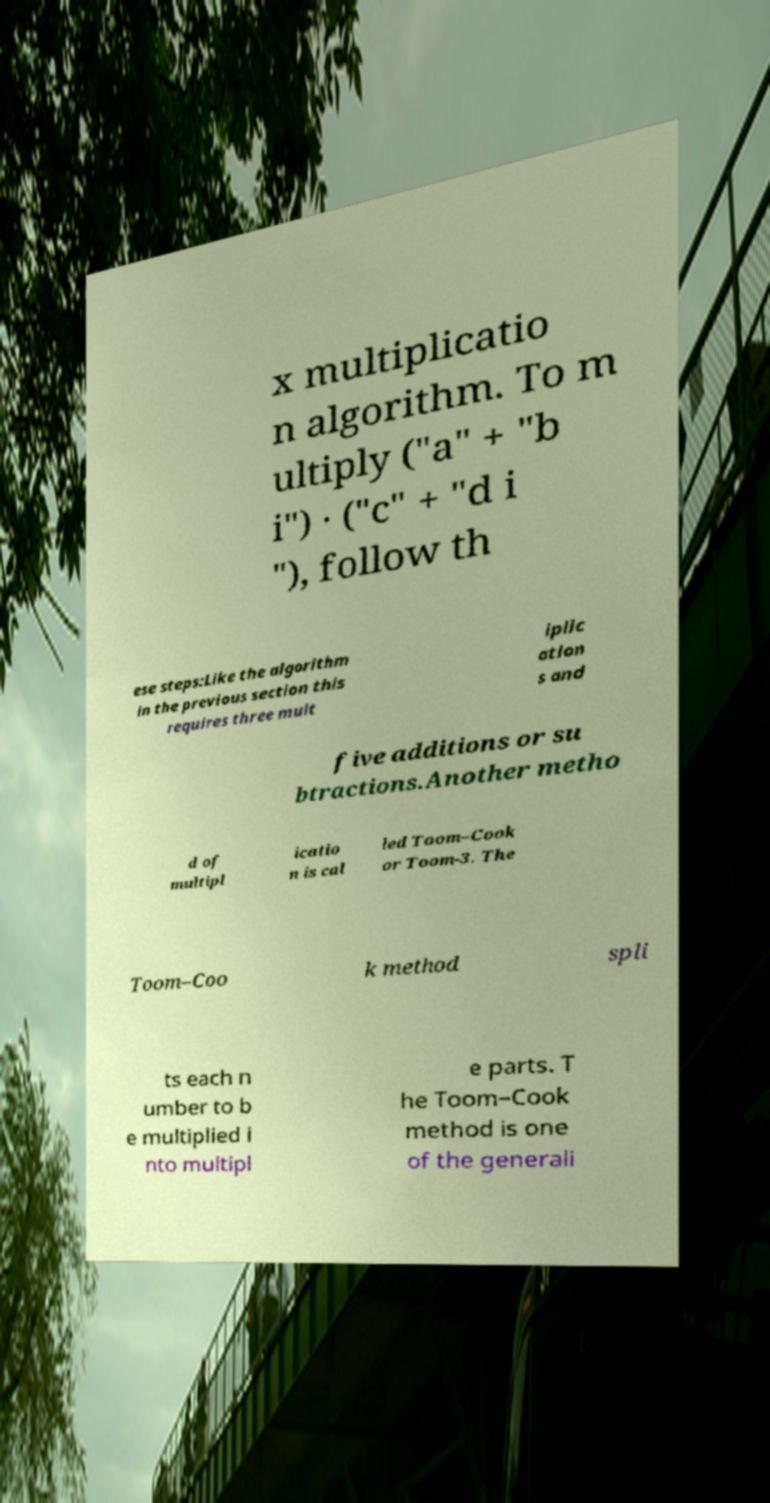What messages or text are displayed in this image? I need them in a readable, typed format. x multiplicatio n algorithm. To m ultiply ("a" + "b i") · ("c" + "d i "), follow th ese steps:Like the algorithm in the previous section this requires three mult iplic ation s and five additions or su btractions.Another metho d of multipl icatio n is cal led Toom–Cook or Toom-3. The Toom–Coo k method spli ts each n umber to b e multiplied i nto multipl e parts. T he Toom–Cook method is one of the generali 